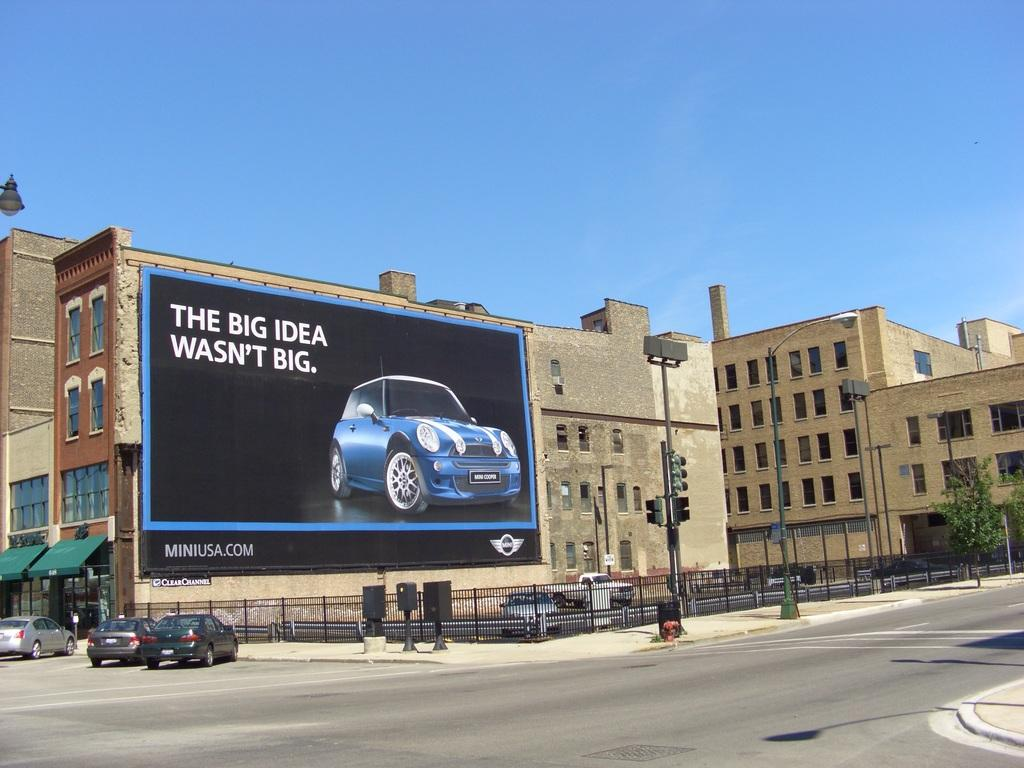<image>
Present a compact description of the photo's key features. A billboard with a blue car says "The big idea wasn't big." 